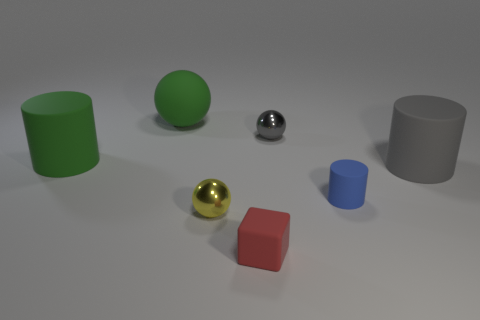Add 2 tiny blue shiny cylinders. How many objects exist? 9 Subtract all spheres. How many objects are left? 4 Subtract all small matte cylinders. Subtract all small gray metallic objects. How many objects are left? 5 Add 1 cylinders. How many cylinders are left? 4 Add 1 small cylinders. How many small cylinders exist? 2 Subtract 1 blue cylinders. How many objects are left? 6 